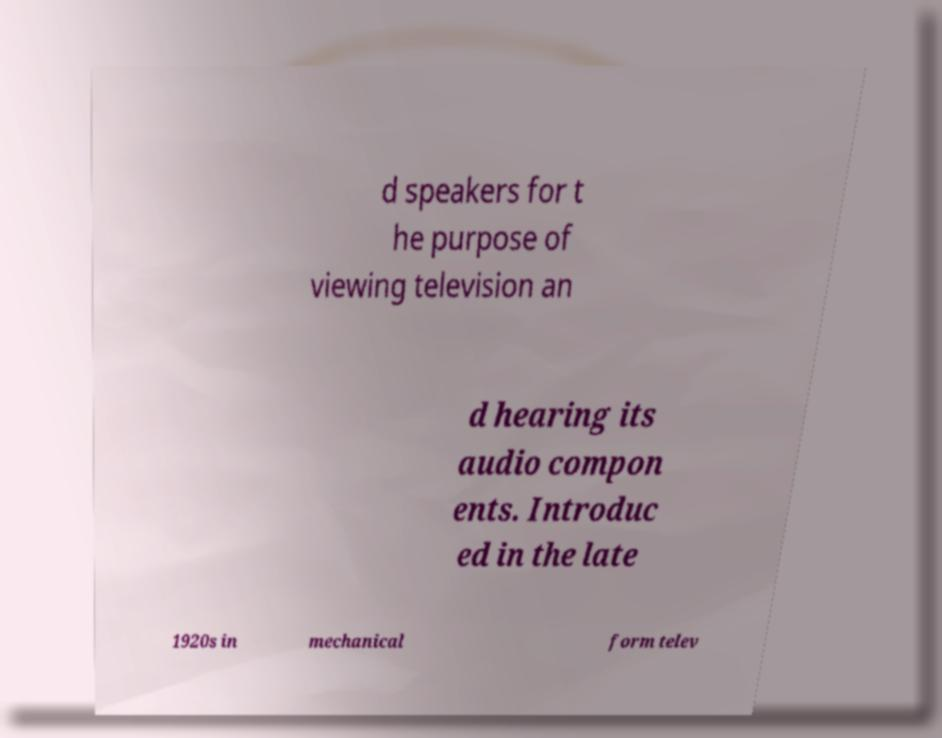Can you accurately transcribe the text from the provided image for me? d speakers for t he purpose of viewing television an d hearing its audio compon ents. Introduc ed in the late 1920s in mechanical form telev 